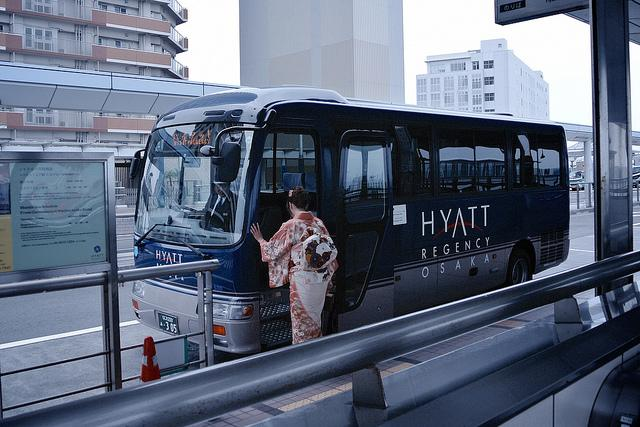In what city is this woman boarding the bus? Please explain your reasoning. osaka. The bus is a shuttle belonging to the hyatt regency hotel chain located in the city that is also written on the side of the bus. 